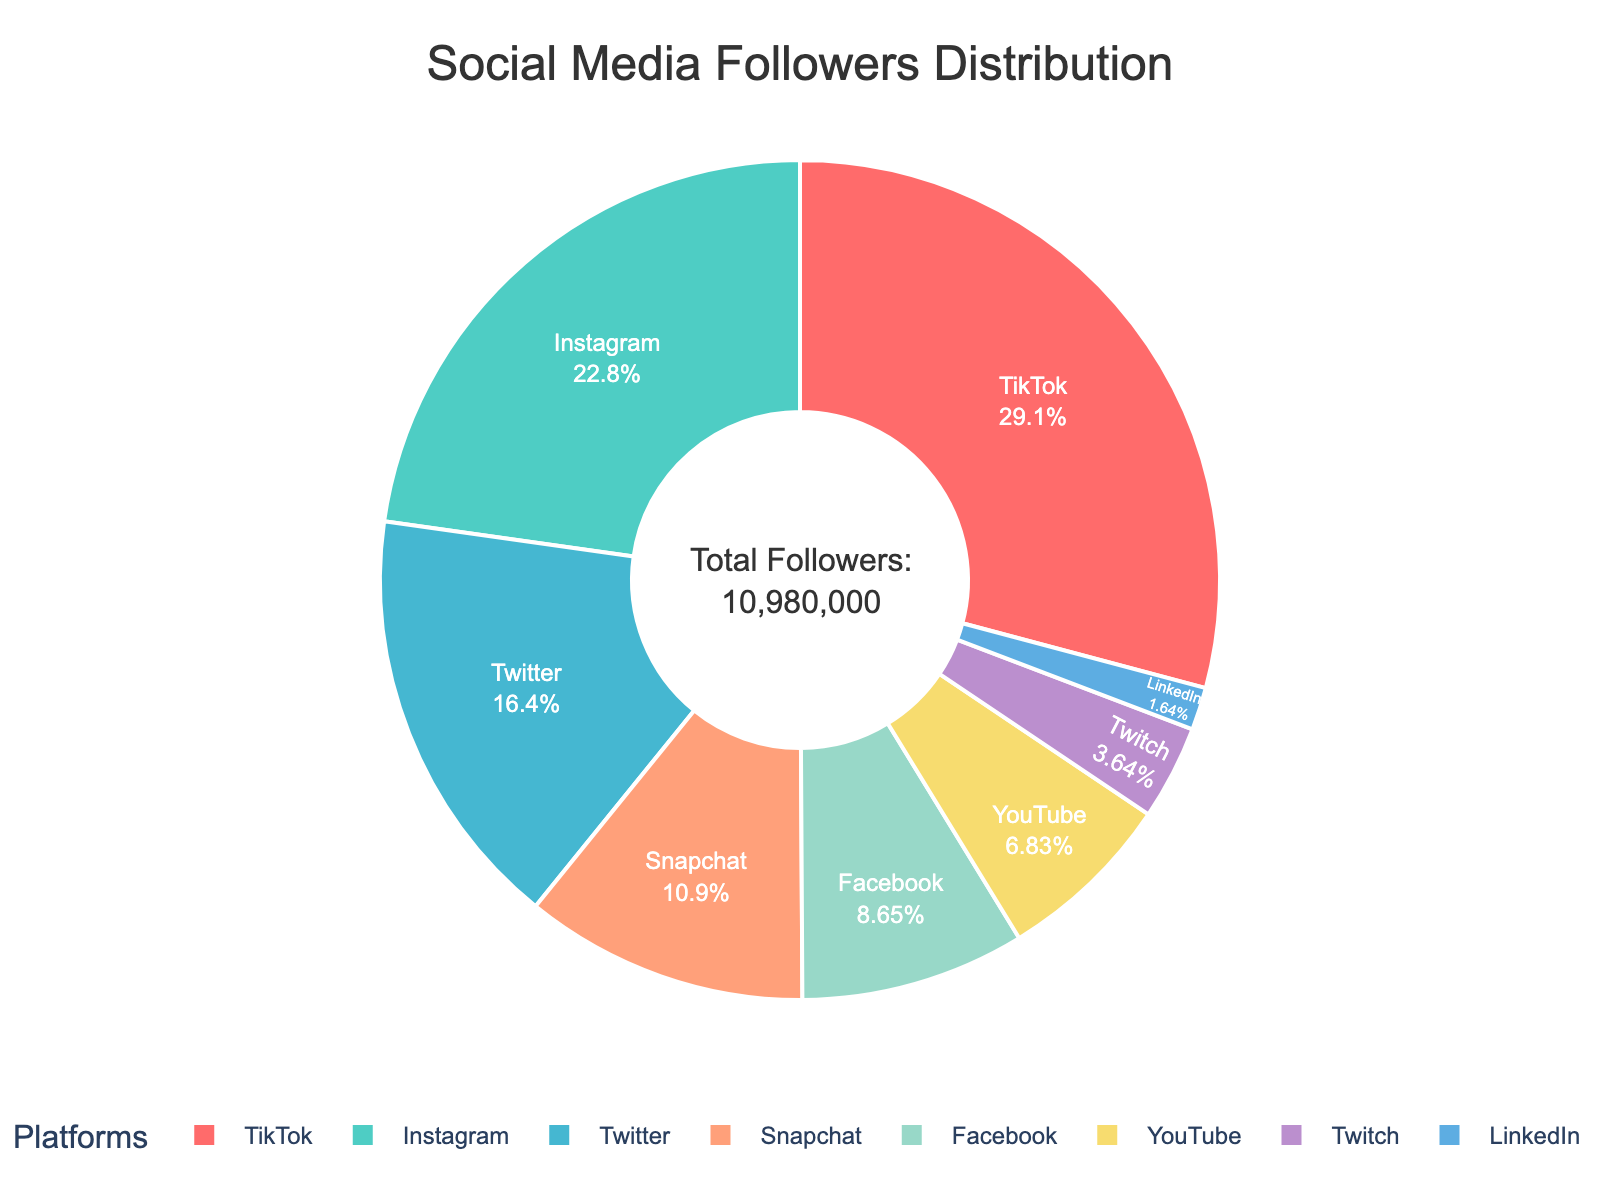Which platform has the highest number of followers? The chart shows that TikTok has the largest segment, which implies it has the highest number of followers relative to the other platforms.
Answer: TikTok How many followers does Facebook have? The figure indicates that Facebook has a specific segment size based on its followers. The segment shows that Facebook has 950,000 followers.
Answer: 950,000 Which platform has fewer followers, YouTube or LinkedIn? By comparing the segments for YouTube and LinkedIn, YouTube has a larger segment than LinkedIn, indicating YouTube has more followers. Therefore, LinkedIn has fewer followers.
Answer: LinkedIn What percentage of the total followers does Twitter have? First, find Twitter's follower count which is 1,800,000. To find the percentage, use (1,800,000 / total followers) * 100. The total followers are 10,615,000. Therefore, (1,800,000 / 10,615,000) * 100 ≈ 16.95%.
Answer: 16.95% How many more followers does Instagram have compared to Twitch? Instagram has 2,500,000 followers and Twitch has 400,000 followers. The difference is 2,500,000 - 400,000 = 2,100,000.
Answer: 2,100,000 What is the combined number of followers for Instagram and Snapchat? Instagram has 2,500,000 followers and Snapchat has 1,200,000 followers. Adding them together, 2,500,000 + 1,200,000 = 3,700,000.
Answer: 3,700,000 Which platform has the smallest number of followers? The chart shows the smallest segment corresponds to LinkedIn, which means it has the smallest number of followers.
Answer: LinkedIn How does the number of TikTok followers compare to the number of Facebook followers? TikTok has 3,200,000 followers, and Facebook has 950,000 followers. TikTok has more followers than Facebook.
Answer: TikTok has more What is the ratio of Snapchat followers to YouTube followers? Snapchat has 1,200,000 followers and YouTube has 750,000 followers. The ratio of Snapchat followers to YouTube followers is 1,200,000:750,000, which simplifies to 8:5.
Answer: 8:5 What is the difference between the number of Instagram followers and YouTube followers? Instagram has 2,500,000 followers, and YouTube has 750,000 followers. The difference is 2,500,000 - 750,000 = 1,750,000.
Answer: 1,750,000 